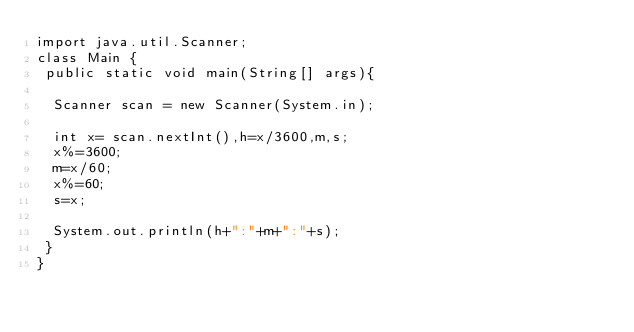Convert code to text. <code><loc_0><loc_0><loc_500><loc_500><_Java_>import java.util.Scanner;
class Main {
 public static void main(String[] args){
 
  Scanner scan = new Scanner(System.in);
  
  int x= scan.nextInt(),h=x/3600,m,s;
  x%=3600;
  m=x/60;
  x%=60; 
  s=x;
 
  System.out.println(h+":"+m+":"+s);
 }
}</code> 